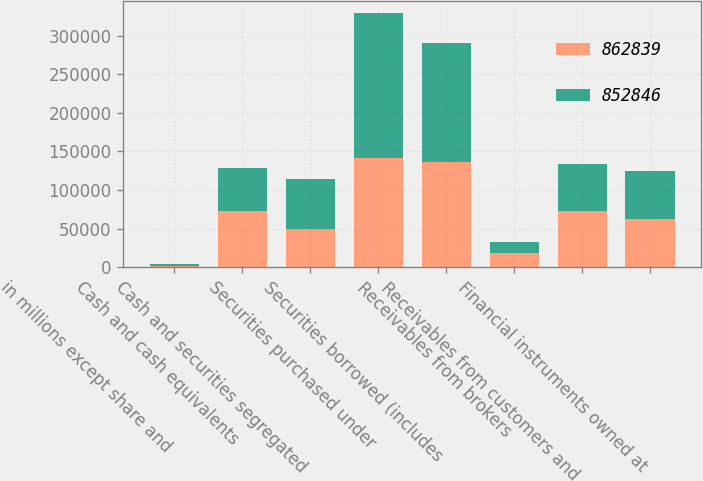<chart> <loc_0><loc_0><loc_500><loc_500><stacked_bar_chart><ecel><fcel>in millions except share and<fcel>Cash and cash equivalents<fcel>Cash and securities segregated<fcel>Securities purchased under<fcel>Securities borrowed (includes<fcel>Receivables from brokers<fcel>Receivables from customers and<fcel>Financial instruments owned at<nl><fcel>862839<fcel>2012<fcel>72669<fcel>49671<fcel>141334<fcel>136893<fcel>18480<fcel>72874<fcel>62262.5<nl><fcel>852846<fcel>2011<fcel>56008<fcel>64264<fcel>187789<fcel>153341<fcel>14204<fcel>60261<fcel>62262.5<nl></chart> 